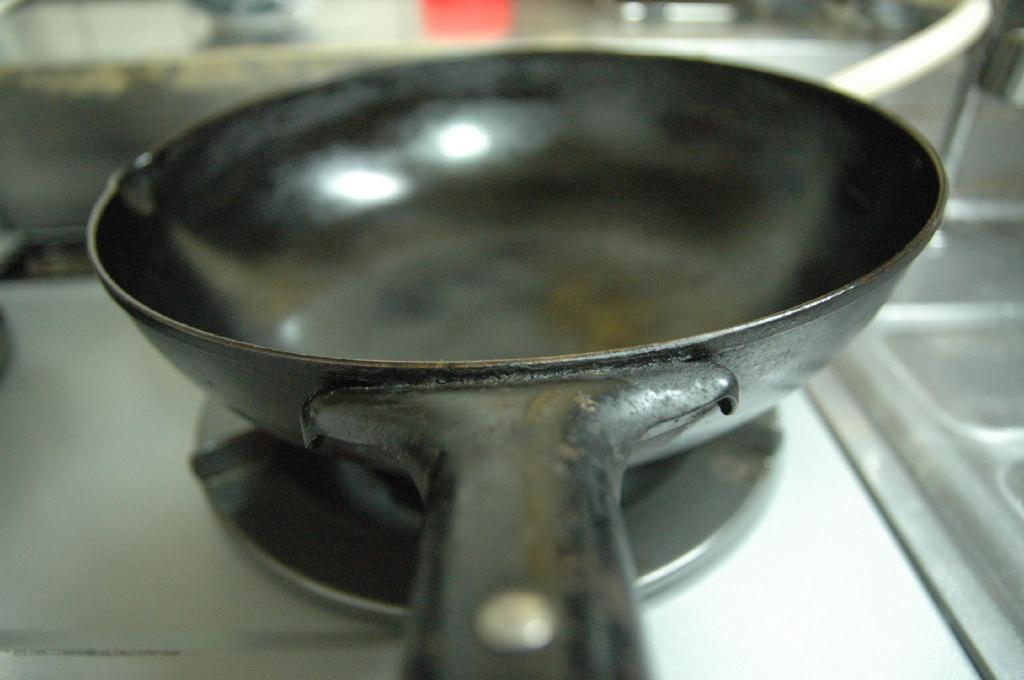What type of pan is visible in the image? There is a black pan in the image. Where is the pan located in the image? The pan is placed on a gas stove. What color is the ink in the basin in the image? There is no basin or ink present in the image. 